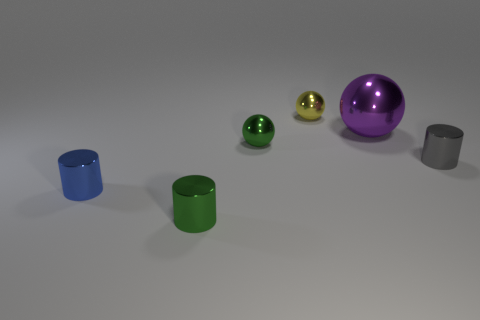Subtract all small balls. How many balls are left? 1 Add 2 large red metallic objects. How many objects exist? 8 Subtract 2 cylinders. How many cylinders are left? 1 Subtract all blue cylinders. How many cylinders are left? 2 Subtract all big brown matte cubes. Subtract all spheres. How many objects are left? 3 Add 5 small cylinders. How many small cylinders are left? 8 Add 6 blue things. How many blue things exist? 7 Subtract 1 purple balls. How many objects are left? 5 Subtract all blue cylinders. Subtract all purple cubes. How many cylinders are left? 2 Subtract all brown cubes. How many blue balls are left? 0 